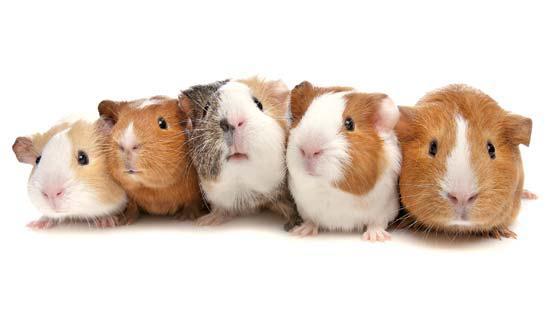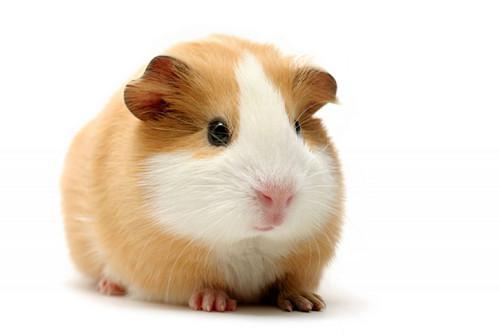The first image is the image on the left, the second image is the image on the right. Assess this claim about the two images: "There are two hamsters in total.". Correct or not? Answer yes or no. No. 